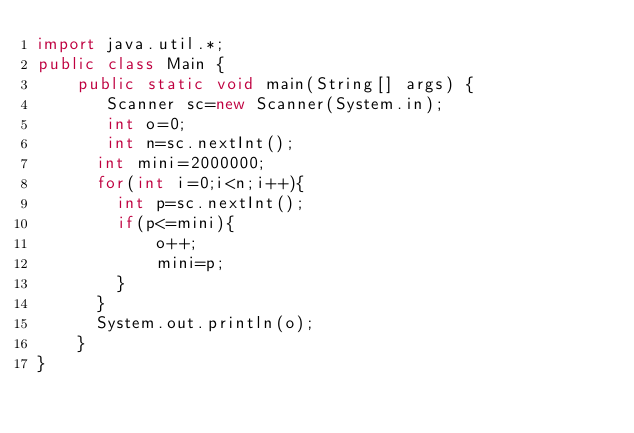<code> <loc_0><loc_0><loc_500><loc_500><_Java_>import java.util.*;
public class Main { 
    public static void main(String[] args) {
       Scanner sc=new Scanner(System.in);
       int o=0;
       int n=sc.nextInt();
      int mini=2000000;
      for(int i=0;i<n;i++){
      	int p=sc.nextInt();
        if(p<=mini){
        	o++;
            mini=p;
        }
      }
      System.out.println(o);
    }
}</code> 